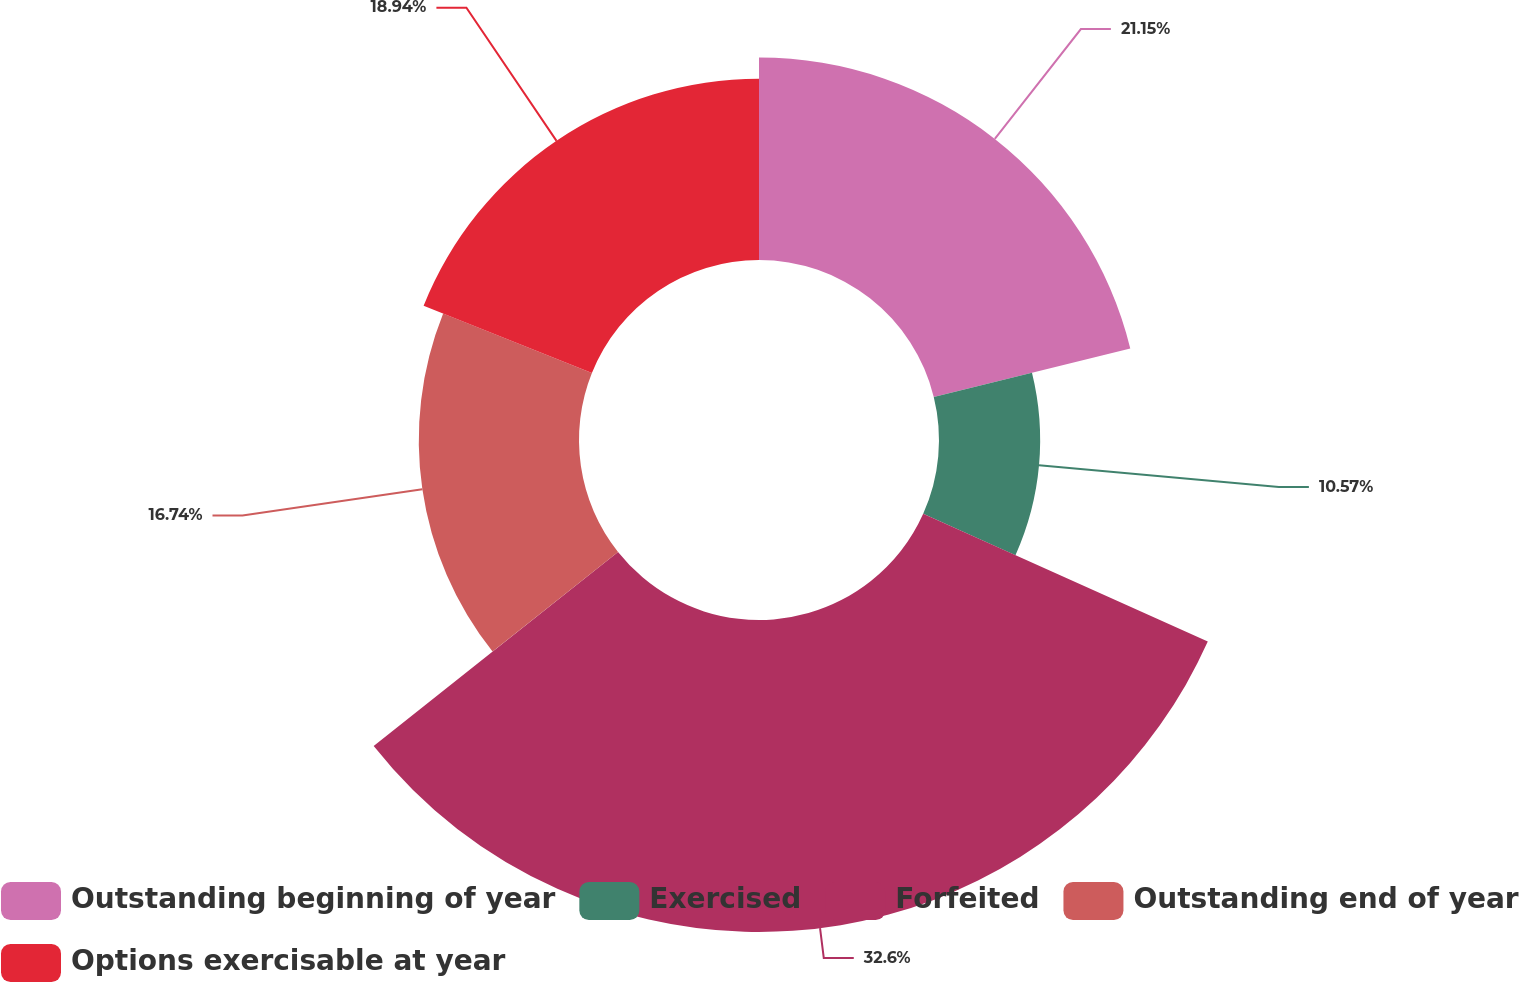<chart> <loc_0><loc_0><loc_500><loc_500><pie_chart><fcel>Outstanding beginning of year<fcel>Exercised<fcel>Forfeited<fcel>Outstanding end of year<fcel>Options exercisable at year<nl><fcel>21.15%<fcel>10.57%<fcel>32.6%<fcel>16.74%<fcel>18.94%<nl></chart> 